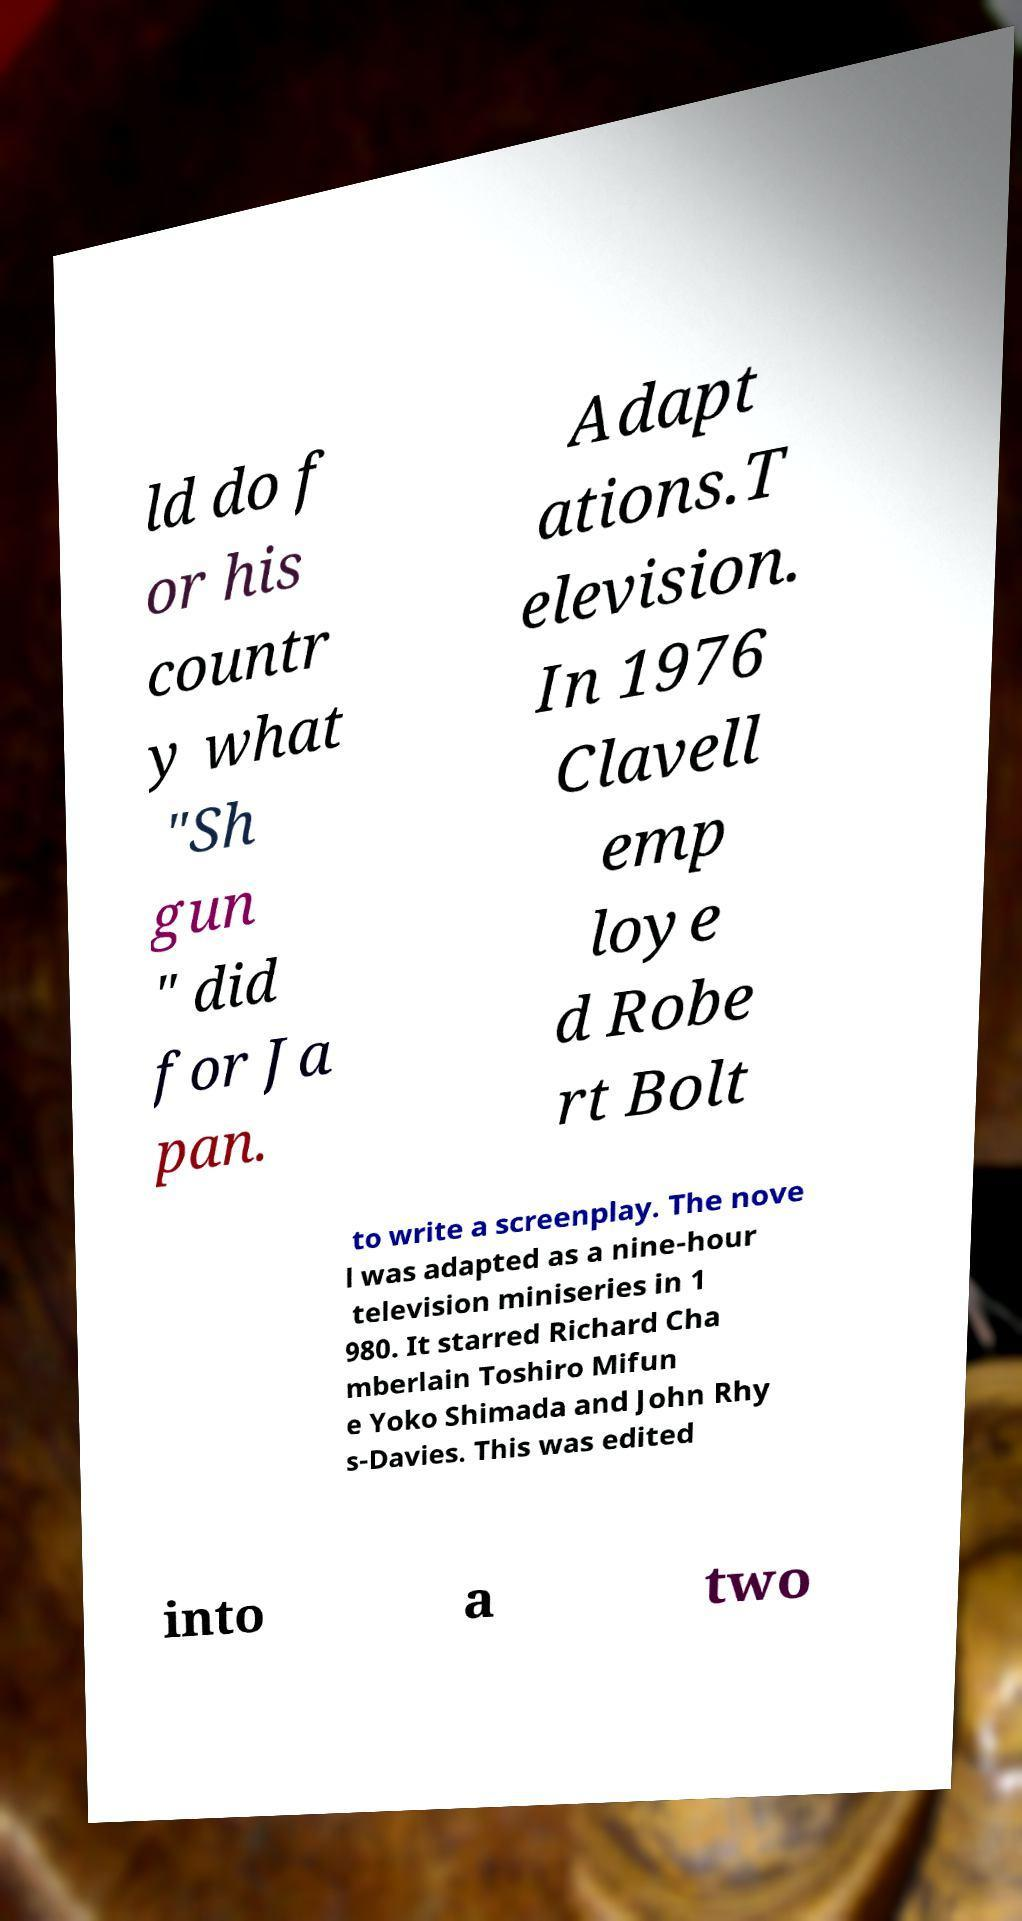I need the written content from this picture converted into text. Can you do that? ld do f or his countr y what "Sh gun " did for Ja pan. Adapt ations.T elevision. In 1976 Clavell emp loye d Robe rt Bolt to write a screenplay. The nove l was adapted as a nine-hour television miniseries in 1 980. It starred Richard Cha mberlain Toshiro Mifun e Yoko Shimada and John Rhy s-Davies. This was edited into a two 